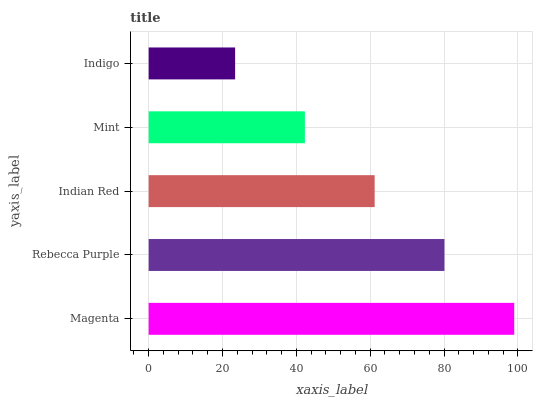Is Indigo the minimum?
Answer yes or no. Yes. Is Magenta the maximum?
Answer yes or no. Yes. Is Rebecca Purple the minimum?
Answer yes or no. No. Is Rebecca Purple the maximum?
Answer yes or no. No. Is Magenta greater than Rebecca Purple?
Answer yes or no. Yes. Is Rebecca Purple less than Magenta?
Answer yes or no. Yes. Is Rebecca Purple greater than Magenta?
Answer yes or no. No. Is Magenta less than Rebecca Purple?
Answer yes or no. No. Is Indian Red the high median?
Answer yes or no. Yes. Is Indian Red the low median?
Answer yes or no. Yes. Is Indigo the high median?
Answer yes or no. No. Is Indigo the low median?
Answer yes or no. No. 